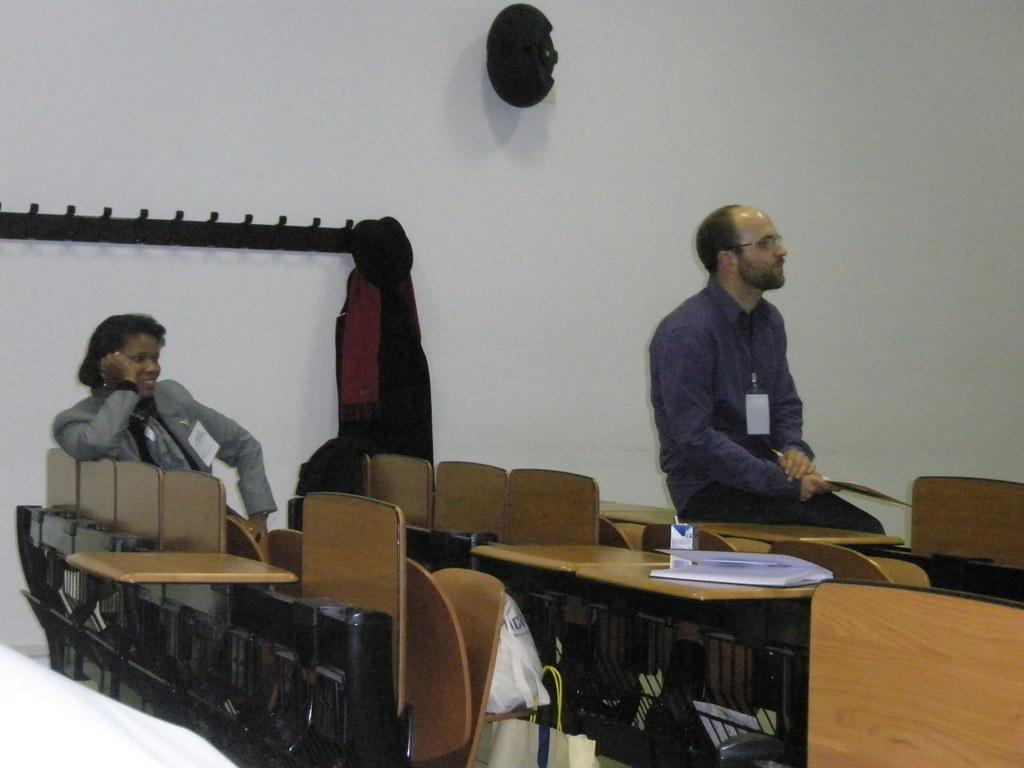How many people are in the image? There are two people in the image. Can you describe the positions of the people in the image? A woman is on the left side of the image, and a man is on the right side of the image. What is the man doing in the image? The man is sitting on a table in the image. What items can be seen hanging on the wall? There is a cap and a dress on a hanger on the wall in the image. Can you tell me how many rivers are visible in the image? There are no rivers visible in the image. Is the man walking in the image? The man is sitting on a table in the image, so he is not walking. 